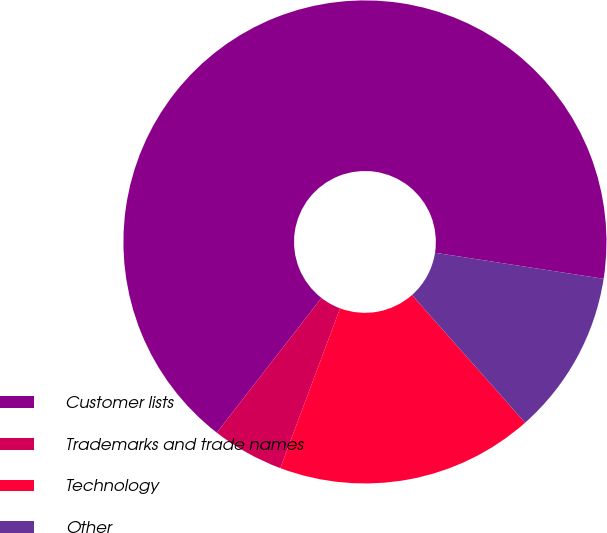<chart> <loc_0><loc_0><loc_500><loc_500><pie_chart><fcel>Customer lists<fcel>Trademarks and trade names<fcel>Technology<fcel>Other<nl><fcel>66.93%<fcel>4.81%<fcel>17.24%<fcel>11.02%<nl></chart> 